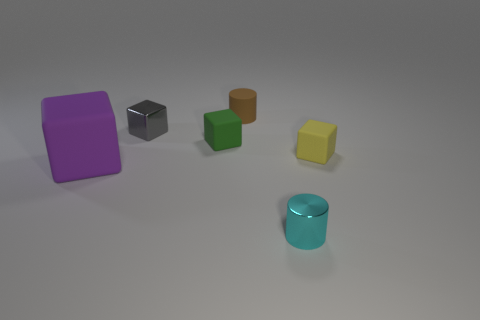There is a metal cylinder; what number of brown cylinders are in front of it?
Your answer should be very brief. 0. Are the purple cube and the cylinder that is behind the big purple matte thing made of the same material?
Make the answer very short. Yes. Is there a rubber cylinder that has the same size as the yellow matte cube?
Make the answer very short. Yes. Are there an equal number of green rubber things left of the gray shiny block and rubber cylinders?
Your answer should be very brief. No. What is the size of the brown cylinder?
Your answer should be very brief. Small. There is a cylinder that is to the left of the cyan metal cylinder; what number of small gray cubes are behind it?
Ensure brevity in your answer.  0. What shape is the object that is both in front of the small green matte cube and left of the cyan thing?
Make the answer very short. Cube. Are there any tiny rubber things that are right of the tiny thing that is in front of the tiny cube in front of the green matte thing?
Your answer should be compact. Yes. How big is the object that is both behind the tiny yellow matte object and in front of the gray metal object?
Offer a very short reply. Small. How many brown things are made of the same material as the small green block?
Provide a short and direct response. 1. 